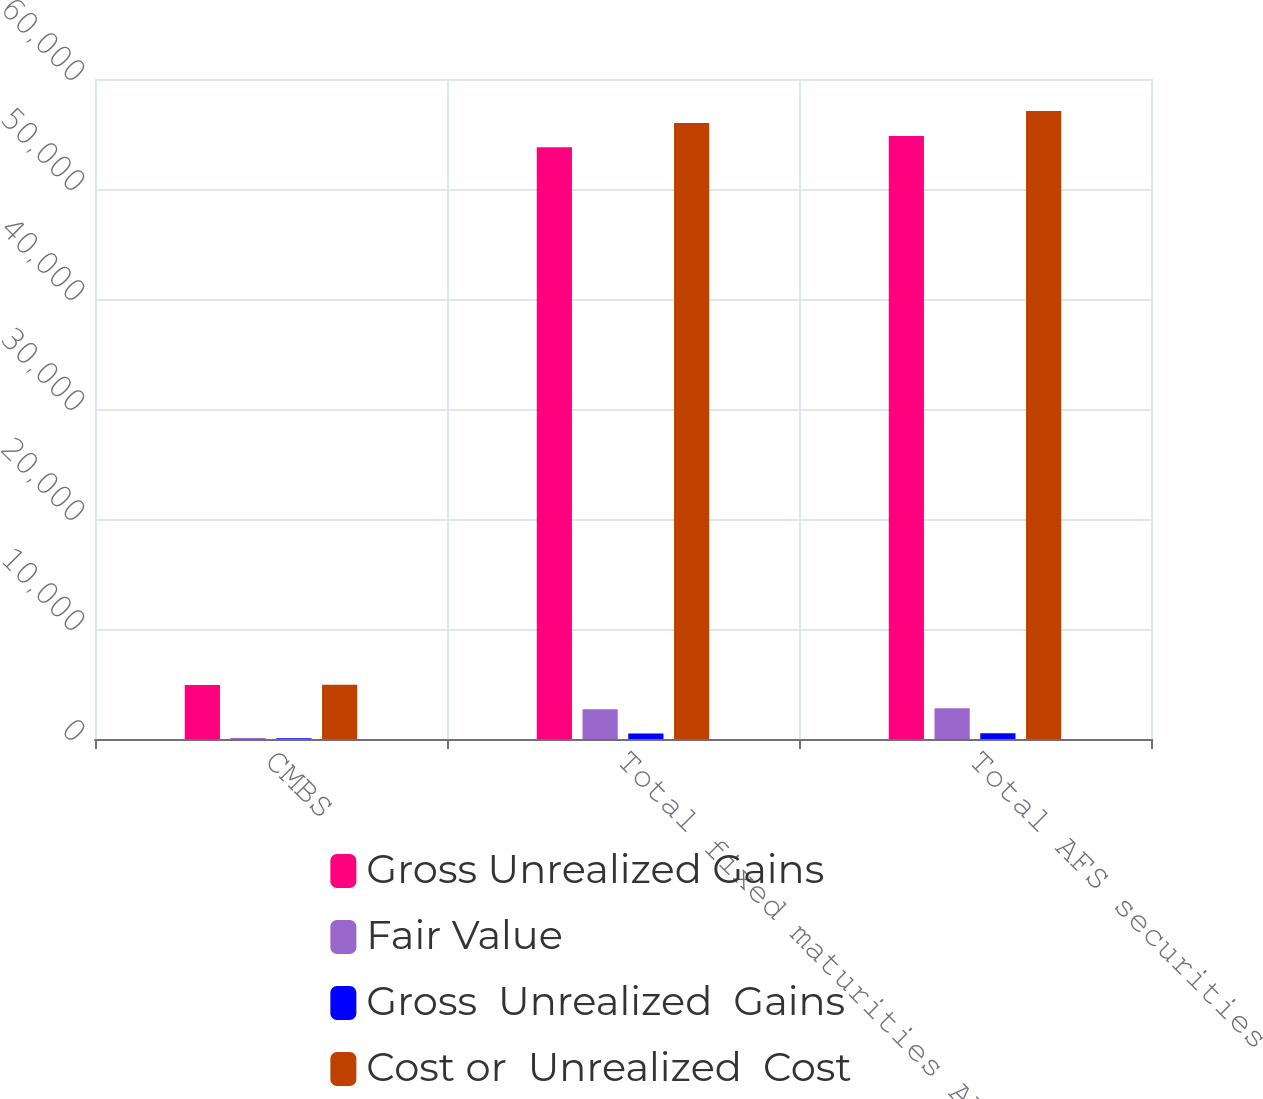<chart> <loc_0><loc_0><loc_500><loc_500><stacked_bar_chart><ecel><fcel>CMBS<fcel>Total fixed maturities AFS<fcel>Total AFS securities<nl><fcel>Gross Unrealized Gains<fcel>4907<fcel>53805<fcel>54825<nl><fcel>Fair Value<fcel>97<fcel>2704<fcel>2800<nl><fcel>Gross  Unrealized  Gains<fcel>68<fcel>506<fcel>525<nl><fcel>Cost or  Unrealized  Cost<fcel>4936<fcel>56003<fcel>57100<nl></chart> 